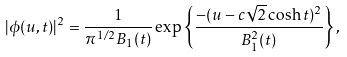Convert formula to latex. <formula><loc_0><loc_0><loc_500><loc_500>| \phi ( u , t ) | ^ { 2 } = \frac { 1 } { \pi ^ { 1 / 2 } B _ { 1 } ( t ) } \exp \left \{ \frac { - ( u - c \sqrt { 2 } \cosh t ) ^ { 2 } } { B _ { 1 } ^ { 2 } ( t ) } \right \} ,</formula> 